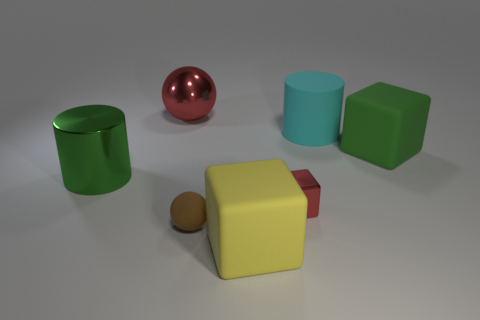How big is the metallic thing that is behind the large green object right of the red thing that is on the right side of the yellow matte thing?
Provide a succinct answer. Large. How many objects are big green things that are on the right side of the matte cylinder or large metal objects?
Your answer should be very brief. 3. There is a large cylinder that is on the right side of the tiny cube; what number of green things are on the left side of it?
Your answer should be compact. 1. Are there more rubber things that are on the right side of the small red shiny object than large gray shiny things?
Keep it short and to the point. Yes. How big is the metal object that is both in front of the large shiny sphere and on the left side of the yellow matte object?
Your answer should be very brief. Large. What shape is the big object that is both right of the red block and behind the large green matte cube?
Keep it short and to the point. Cylinder. Is there a big red metal sphere that is to the right of the big matte block behind the big cylinder that is left of the brown ball?
Give a very brief answer. No. What number of objects are either cylinders that are on the left side of the large rubber cylinder or green objects left of the cyan matte object?
Provide a succinct answer. 1. Is the material of the large cube to the left of the tiny red shiny thing the same as the small red cube?
Provide a succinct answer. No. What is the material of the cube that is to the left of the cyan matte object and behind the large yellow block?
Your answer should be very brief. Metal. 